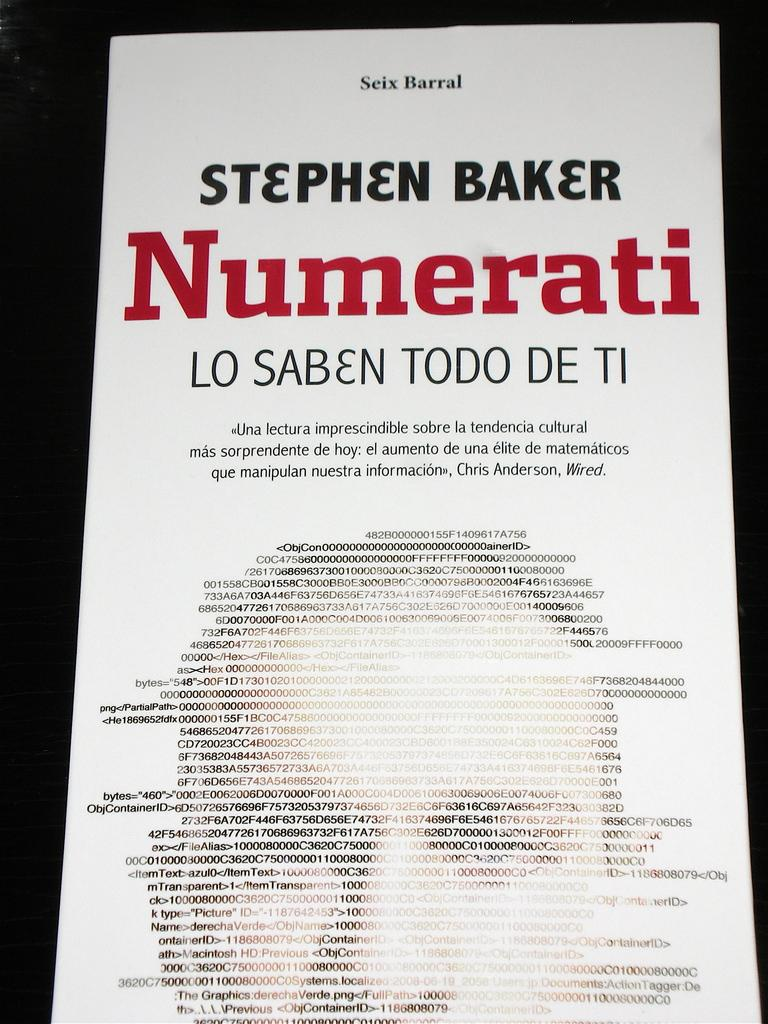What is present in the image that contains text? There is a poster in the image that contains text. Can you describe the text on the poster? The text at the bottom of the poster is in the form of a human face. What type of spark can be seen coming from the bucket in the image? There is no bucket or spark present in the image. 